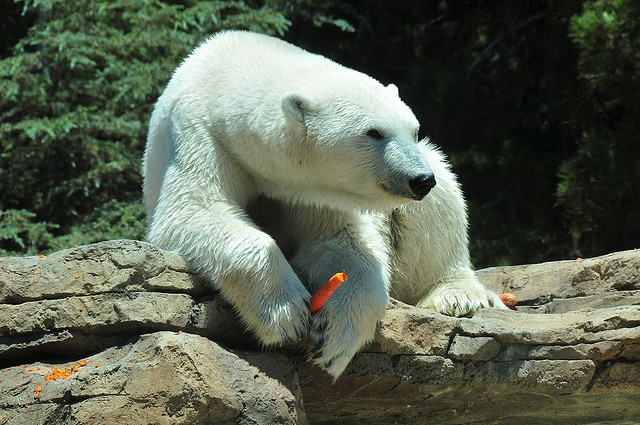Describe the objects in this image and their specific colors. I can see bear in black, ivory, gray, and darkgray tones, carrot in black, brown, and maroon tones, and carrot in black, brown, and tan tones in this image. 